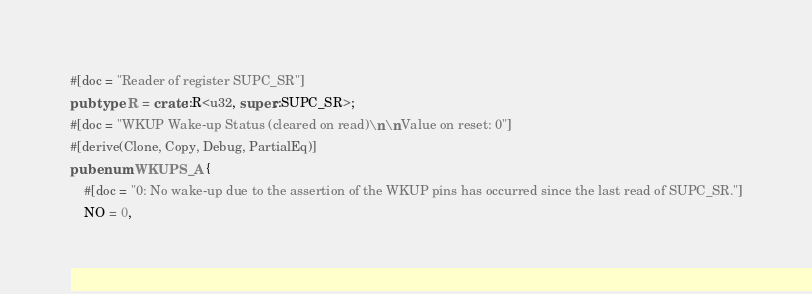Convert code to text. <code><loc_0><loc_0><loc_500><loc_500><_Rust_>#[doc = "Reader of register SUPC_SR"]
pub type R = crate::R<u32, super::SUPC_SR>;
#[doc = "WKUP Wake-up Status (cleared on read)\n\nValue on reset: 0"]
#[derive(Clone, Copy, Debug, PartialEq)]
pub enum WKUPS_A {
    #[doc = "0: No wake-up due to the assertion of the WKUP pins has occurred since the last read of SUPC_SR."]
    NO = 0,</code> 